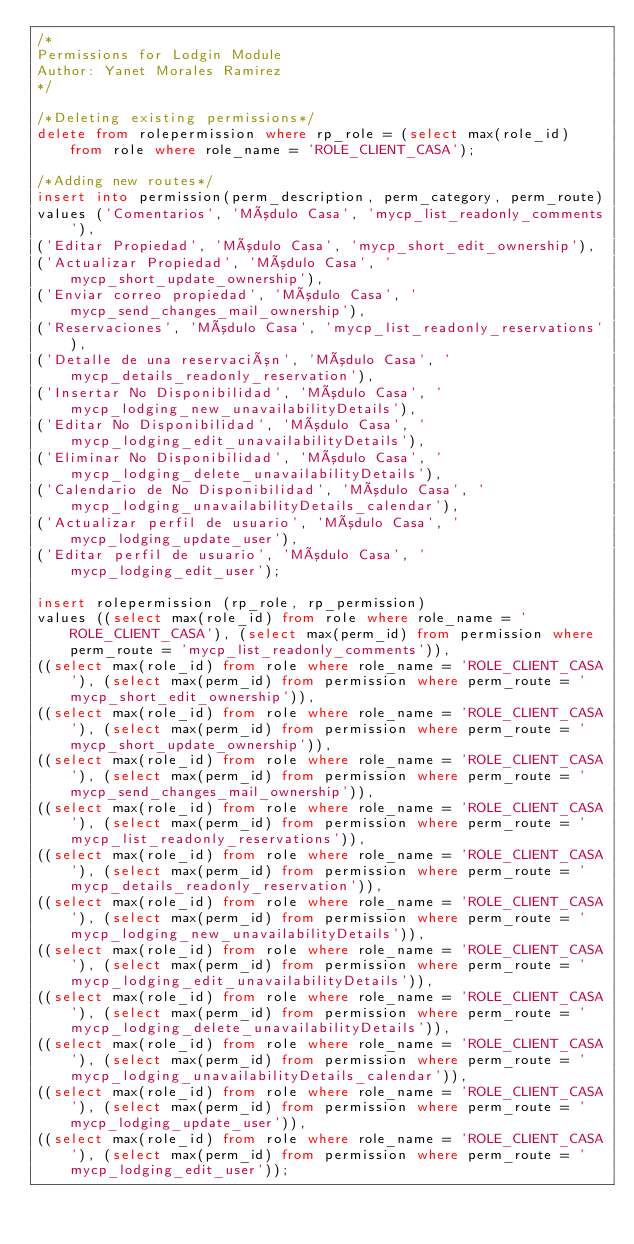<code> <loc_0><loc_0><loc_500><loc_500><_SQL_>/*
Permissions for Lodgin Module
Author: Yanet Morales Ramirez
*/

/*Deleting existing permissions*/
delete from rolepermission where rp_role = (select max(role_id) from role where role_name = 'ROLE_CLIENT_CASA');

/*Adding new routes*/
insert into permission(perm_description, perm_category, perm_route)
values ('Comentarios', 'Módulo Casa', 'mycp_list_readonly_comments'),
('Editar Propiedad', 'Módulo Casa', 'mycp_short_edit_ownership'),
('Actualizar Propiedad', 'Módulo Casa', 'mycp_short_update_ownership'),
('Enviar correo propiedad', 'Módulo Casa', 'mycp_send_changes_mail_ownership'),
('Reservaciones', 'Módulo Casa', 'mycp_list_readonly_reservations'),
('Detalle de una reservación', 'Módulo Casa', 'mycp_details_readonly_reservation'),
('Insertar No Disponibilidad', 'Módulo Casa', 'mycp_lodging_new_unavailabilityDetails'),
('Editar No Disponibilidad', 'Módulo Casa', 'mycp_lodging_edit_unavailabilityDetails'),
('Eliminar No Disponibilidad', 'Módulo Casa', 'mycp_lodging_delete_unavailabilityDetails'),
('Calendario de No Disponibilidad', 'Módulo Casa', 'mycp_lodging_unavailabilityDetails_calendar'),
('Actualizar perfil de usuario', 'Módulo Casa', 'mycp_lodging_update_user'),
('Editar perfil de usuario', 'Módulo Casa', 'mycp_lodging_edit_user');

insert rolepermission (rp_role, rp_permission)
values ((select max(role_id) from role where role_name = 'ROLE_CLIENT_CASA'), (select max(perm_id) from permission where perm_route = 'mycp_list_readonly_comments')),
((select max(role_id) from role where role_name = 'ROLE_CLIENT_CASA'), (select max(perm_id) from permission where perm_route = 'mycp_short_edit_ownership')),
((select max(role_id) from role where role_name = 'ROLE_CLIENT_CASA'), (select max(perm_id) from permission where perm_route = 'mycp_short_update_ownership')),
((select max(role_id) from role where role_name = 'ROLE_CLIENT_CASA'), (select max(perm_id) from permission where perm_route = 'mycp_send_changes_mail_ownership')),
((select max(role_id) from role where role_name = 'ROLE_CLIENT_CASA'), (select max(perm_id) from permission where perm_route = 'mycp_list_readonly_reservations')),
((select max(role_id) from role where role_name = 'ROLE_CLIENT_CASA'), (select max(perm_id) from permission where perm_route = 'mycp_details_readonly_reservation')),
((select max(role_id) from role where role_name = 'ROLE_CLIENT_CASA'), (select max(perm_id) from permission where perm_route = 'mycp_lodging_new_unavailabilityDetails')),
((select max(role_id) from role where role_name = 'ROLE_CLIENT_CASA'), (select max(perm_id) from permission where perm_route = 'mycp_lodging_edit_unavailabilityDetails')),
((select max(role_id) from role where role_name = 'ROLE_CLIENT_CASA'), (select max(perm_id) from permission where perm_route = 'mycp_lodging_delete_unavailabilityDetails')),
((select max(role_id) from role where role_name = 'ROLE_CLIENT_CASA'), (select max(perm_id) from permission where perm_route = 'mycp_lodging_unavailabilityDetails_calendar')),
((select max(role_id) from role where role_name = 'ROLE_CLIENT_CASA'), (select max(perm_id) from permission where perm_route = 'mycp_lodging_update_user')),
((select max(role_id) from role where role_name = 'ROLE_CLIENT_CASA'), (select max(perm_id) from permission where perm_route = 'mycp_lodging_edit_user'));</code> 